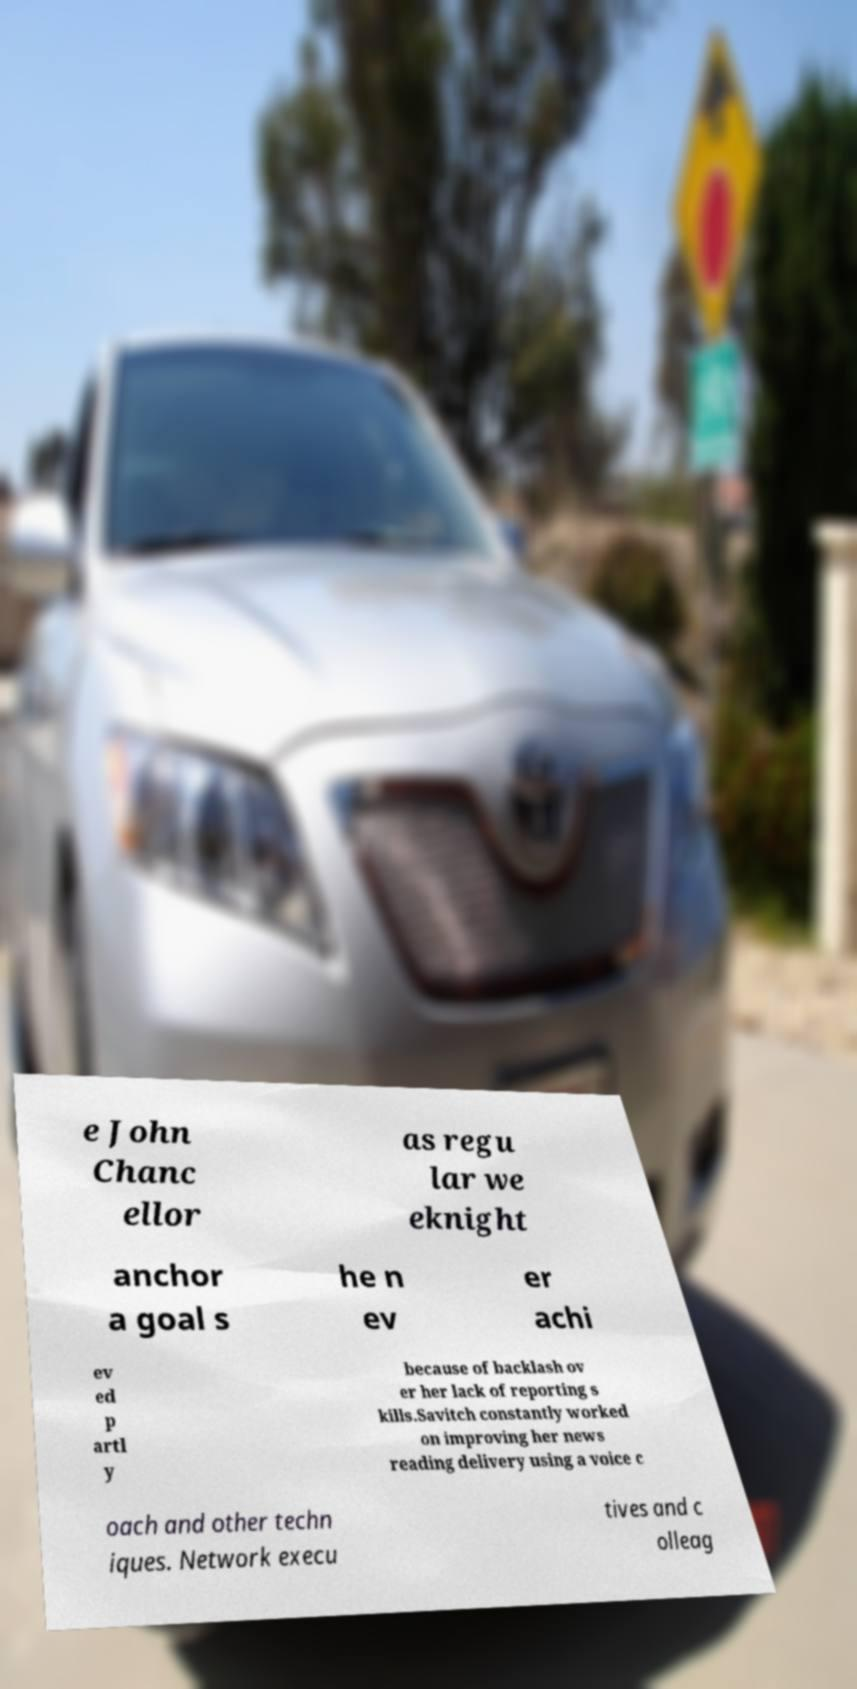I need the written content from this picture converted into text. Can you do that? e John Chanc ellor as regu lar we eknight anchor a goal s he n ev er achi ev ed p artl y because of backlash ov er her lack of reporting s kills.Savitch constantly worked on improving her news reading delivery using a voice c oach and other techn iques. Network execu tives and c olleag 